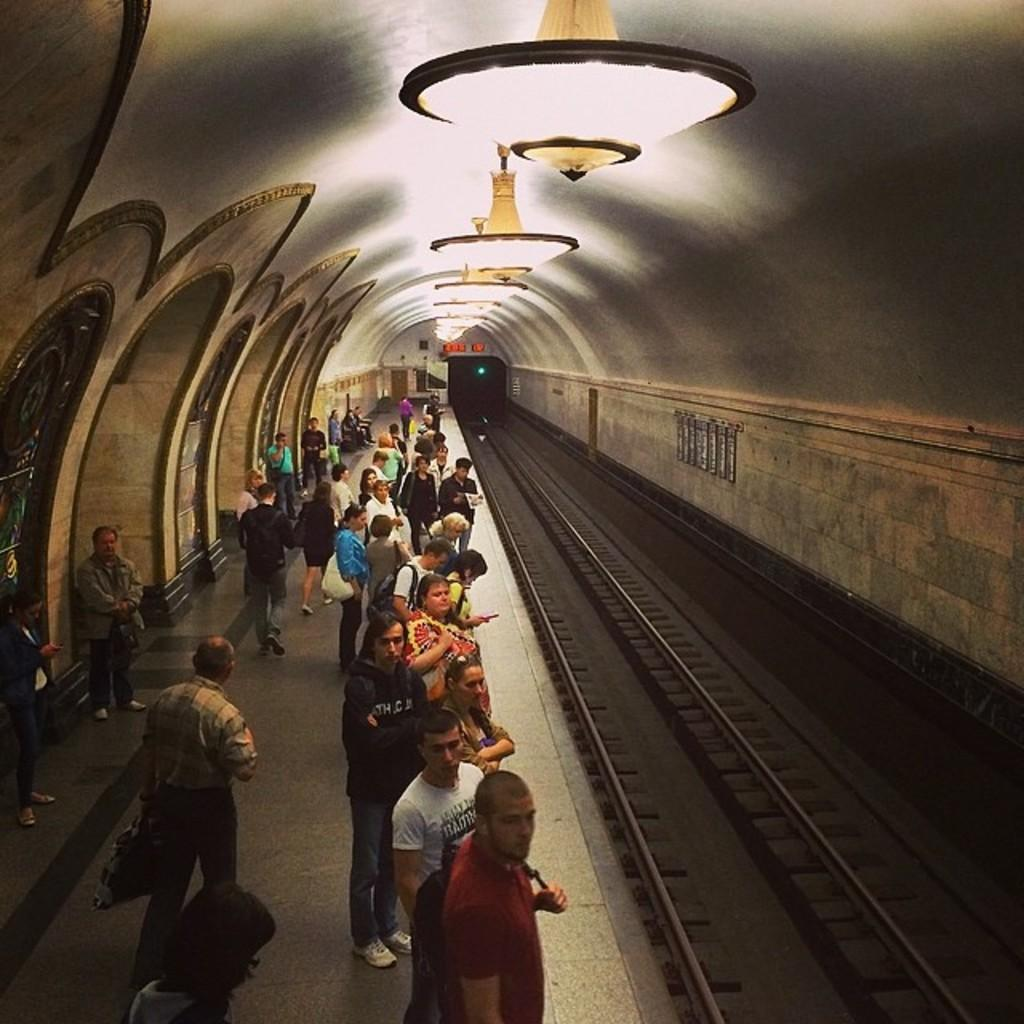How many people are in the image? There is a group of people in the image, but the exact number is not specified. Where are the people standing in the image? The people are standing on a railway platform. What can be seen on the right side of the image? There are railway tracks on the right side of the image. What is visible in the distance in the image? There is a tunnel visible in the image. What might be used for illumination in the image? There are lights present in the image. What type of blade can be seen cutting through the tunnel in the image? There is no blade present in the image, and the tunnel is not being cut through. 